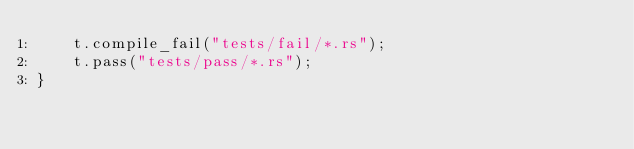<code> <loc_0><loc_0><loc_500><loc_500><_Rust_>    t.compile_fail("tests/fail/*.rs");
    t.pass("tests/pass/*.rs");
}
</code> 